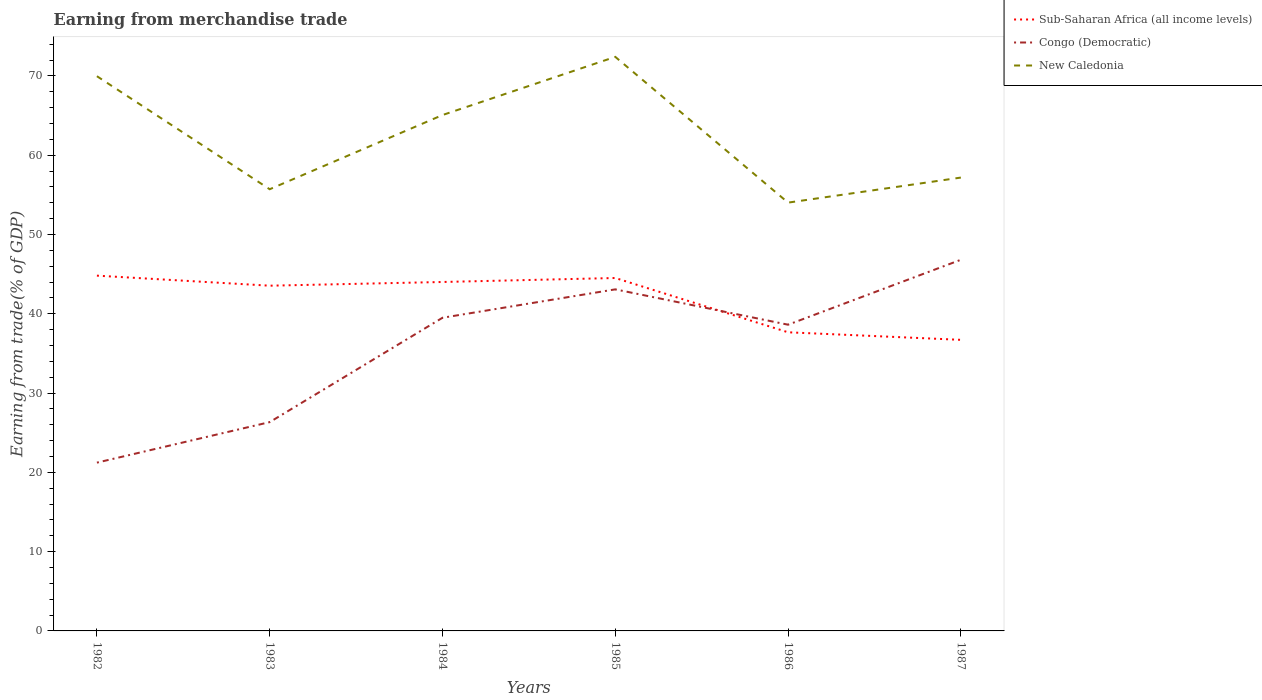Does the line corresponding to Congo (Democratic) intersect with the line corresponding to Sub-Saharan Africa (all income levels)?
Give a very brief answer. Yes. Across all years, what is the maximum earnings from trade in Congo (Democratic)?
Your response must be concise. 21.23. In which year was the earnings from trade in New Caledonia maximum?
Your answer should be very brief. 1986. What is the total earnings from trade in Sub-Saharan Africa (all income levels) in the graph?
Provide a short and direct response. 7.8. What is the difference between the highest and the second highest earnings from trade in Sub-Saharan Africa (all income levels)?
Make the answer very short. 8.1. How many lines are there?
Ensure brevity in your answer.  3. How many years are there in the graph?
Give a very brief answer. 6. Are the values on the major ticks of Y-axis written in scientific E-notation?
Keep it short and to the point. No. Where does the legend appear in the graph?
Provide a short and direct response. Top right. How many legend labels are there?
Offer a terse response. 3. How are the legend labels stacked?
Provide a succinct answer. Vertical. What is the title of the graph?
Offer a terse response. Earning from merchandise trade. Does "Togo" appear as one of the legend labels in the graph?
Provide a succinct answer. No. What is the label or title of the X-axis?
Offer a terse response. Years. What is the label or title of the Y-axis?
Provide a succinct answer. Earning from trade(% of GDP). What is the Earning from trade(% of GDP) of Sub-Saharan Africa (all income levels) in 1982?
Provide a short and direct response. 44.81. What is the Earning from trade(% of GDP) in Congo (Democratic) in 1982?
Your response must be concise. 21.23. What is the Earning from trade(% of GDP) in New Caledonia in 1982?
Provide a short and direct response. 69.97. What is the Earning from trade(% of GDP) in Sub-Saharan Africa (all income levels) in 1983?
Ensure brevity in your answer.  43.55. What is the Earning from trade(% of GDP) in Congo (Democratic) in 1983?
Offer a very short reply. 26.34. What is the Earning from trade(% of GDP) of New Caledonia in 1983?
Provide a short and direct response. 55.72. What is the Earning from trade(% of GDP) of Sub-Saharan Africa (all income levels) in 1984?
Give a very brief answer. 44.02. What is the Earning from trade(% of GDP) in Congo (Democratic) in 1984?
Give a very brief answer. 39.5. What is the Earning from trade(% of GDP) of New Caledonia in 1984?
Your answer should be very brief. 65.07. What is the Earning from trade(% of GDP) of Sub-Saharan Africa (all income levels) in 1985?
Ensure brevity in your answer.  44.52. What is the Earning from trade(% of GDP) in Congo (Democratic) in 1985?
Give a very brief answer. 43.09. What is the Earning from trade(% of GDP) of New Caledonia in 1985?
Give a very brief answer. 72.41. What is the Earning from trade(% of GDP) of Sub-Saharan Africa (all income levels) in 1986?
Provide a succinct answer. 37.67. What is the Earning from trade(% of GDP) in Congo (Democratic) in 1986?
Your answer should be compact. 38.63. What is the Earning from trade(% of GDP) in New Caledonia in 1986?
Provide a short and direct response. 54.03. What is the Earning from trade(% of GDP) in Sub-Saharan Africa (all income levels) in 1987?
Keep it short and to the point. 36.72. What is the Earning from trade(% of GDP) in Congo (Democratic) in 1987?
Your answer should be very brief. 46.82. What is the Earning from trade(% of GDP) of New Caledonia in 1987?
Provide a succinct answer. 57.19. Across all years, what is the maximum Earning from trade(% of GDP) of Sub-Saharan Africa (all income levels)?
Keep it short and to the point. 44.81. Across all years, what is the maximum Earning from trade(% of GDP) in Congo (Democratic)?
Give a very brief answer. 46.82. Across all years, what is the maximum Earning from trade(% of GDP) in New Caledonia?
Make the answer very short. 72.41. Across all years, what is the minimum Earning from trade(% of GDP) of Sub-Saharan Africa (all income levels)?
Keep it short and to the point. 36.72. Across all years, what is the minimum Earning from trade(% of GDP) of Congo (Democratic)?
Make the answer very short. 21.23. Across all years, what is the minimum Earning from trade(% of GDP) of New Caledonia?
Your response must be concise. 54.03. What is the total Earning from trade(% of GDP) of Sub-Saharan Africa (all income levels) in the graph?
Your response must be concise. 251.28. What is the total Earning from trade(% of GDP) in Congo (Democratic) in the graph?
Your answer should be compact. 215.6. What is the total Earning from trade(% of GDP) in New Caledonia in the graph?
Ensure brevity in your answer.  374.39. What is the difference between the Earning from trade(% of GDP) in Sub-Saharan Africa (all income levels) in 1982 and that in 1983?
Your response must be concise. 1.27. What is the difference between the Earning from trade(% of GDP) in Congo (Democratic) in 1982 and that in 1983?
Keep it short and to the point. -5.11. What is the difference between the Earning from trade(% of GDP) of New Caledonia in 1982 and that in 1983?
Keep it short and to the point. 14.26. What is the difference between the Earning from trade(% of GDP) of Sub-Saharan Africa (all income levels) in 1982 and that in 1984?
Provide a short and direct response. 0.8. What is the difference between the Earning from trade(% of GDP) in Congo (Democratic) in 1982 and that in 1984?
Offer a terse response. -18.27. What is the difference between the Earning from trade(% of GDP) of New Caledonia in 1982 and that in 1984?
Provide a short and direct response. 4.9. What is the difference between the Earning from trade(% of GDP) of Sub-Saharan Africa (all income levels) in 1982 and that in 1985?
Offer a terse response. 0.3. What is the difference between the Earning from trade(% of GDP) in Congo (Democratic) in 1982 and that in 1985?
Offer a terse response. -21.86. What is the difference between the Earning from trade(% of GDP) in New Caledonia in 1982 and that in 1985?
Your response must be concise. -2.44. What is the difference between the Earning from trade(% of GDP) in Sub-Saharan Africa (all income levels) in 1982 and that in 1986?
Offer a very short reply. 7.14. What is the difference between the Earning from trade(% of GDP) of Congo (Democratic) in 1982 and that in 1986?
Your response must be concise. -17.4. What is the difference between the Earning from trade(% of GDP) in New Caledonia in 1982 and that in 1986?
Make the answer very short. 15.95. What is the difference between the Earning from trade(% of GDP) in Sub-Saharan Africa (all income levels) in 1982 and that in 1987?
Provide a short and direct response. 8.1. What is the difference between the Earning from trade(% of GDP) of Congo (Democratic) in 1982 and that in 1987?
Your answer should be compact. -25.59. What is the difference between the Earning from trade(% of GDP) in New Caledonia in 1982 and that in 1987?
Provide a succinct answer. 12.79. What is the difference between the Earning from trade(% of GDP) in Sub-Saharan Africa (all income levels) in 1983 and that in 1984?
Make the answer very short. -0.47. What is the difference between the Earning from trade(% of GDP) in Congo (Democratic) in 1983 and that in 1984?
Offer a very short reply. -13.16. What is the difference between the Earning from trade(% of GDP) of New Caledonia in 1983 and that in 1984?
Provide a succinct answer. -9.36. What is the difference between the Earning from trade(% of GDP) of Sub-Saharan Africa (all income levels) in 1983 and that in 1985?
Ensure brevity in your answer.  -0.97. What is the difference between the Earning from trade(% of GDP) in Congo (Democratic) in 1983 and that in 1985?
Keep it short and to the point. -16.75. What is the difference between the Earning from trade(% of GDP) of New Caledonia in 1983 and that in 1985?
Your answer should be compact. -16.7. What is the difference between the Earning from trade(% of GDP) in Sub-Saharan Africa (all income levels) in 1983 and that in 1986?
Provide a short and direct response. 5.88. What is the difference between the Earning from trade(% of GDP) of Congo (Democratic) in 1983 and that in 1986?
Keep it short and to the point. -12.29. What is the difference between the Earning from trade(% of GDP) in New Caledonia in 1983 and that in 1986?
Give a very brief answer. 1.69. What is the difference between the Earning from trade(% of GDP) of Sub-Saharan Africa (all income levels) in 1983 and that in 1987?
Keep it short and to the point. 6.83. What is the difference between the Earning from trade(% of GDP) of Congo (Democratic) in 1983 and that in 1987?
Provide a succinct answer. -20.48. What is the difference between the Earning from trade(% of GDP) of New Caledonia in 1983 and that in 1987?
Your response must be concise. -1.47. What is the difference between the Earning from trade(% of GDP) of Sub-Saharan Africa (all income levels) in 1984 and that in 1985?
Offer a terse response. -0.5. What is the difference between the Earning from trade(% of GDP) in Congo (Democratic) in 1984 and that in 1985?
Provide a short and direct response. -3.58. What is the difference between the Earning from trade(% of GDP) in New Caledonia in 1984 and that in 1985?
Make the answer very short. -7.34. What is the difference between the Earning from trade(% of GDP) of Sub-Saharan Africa (all income levels) in 1984 and that in 1986?
Offer a terse response. 6.35. What is the difference between the Earning from trade(% of GDP) in Congo (Democratic) in 1984 and that in 1986?
Keep it short and to the point. 0.88. What is the difference between the Earning from trade(% of GDP) of New Caledonia in 1984 and that in 1986?
Offer a terse response. 11.05. What is the difference between the Earning from trade(% of GDP) of Sub-Saharan Africa (all income levels) in 1984 and that in 1987?
Ensure brevity in your answer.  7.3. What is the difference between the Earning from trade(% of GDP) in Congo (Democratic) in 1984 and that in 1987?
Make the answer very short. -7.32. What is the difference between the Earning from trade(% of GDP) in New Caledonia in 1984 and that in 1987?
Make the answer very short. 7.89. What is the difference between the Earning from trade(% of GDP) in Sub-Saharan Africa (all income levels) in 1985 and that in 1986?
Your answer should be very brief. 6.85. What is the difference between the Earning from trade(% of GDP) of Congo (Democratic) in 1985 and that in 1986?
Offer a very short reply. 4.46. What is the difference between the Earning from trade(% of GDP) of New Caledonia in 1985 and that in 1986?
Ensure brevity in your answer.  18.39. What is the difference between the Earning from trade(% of GDP) of Sub-Saharan Africa (all income levels) in 1985 and that in 1987?
Give a very brief answer. 7.8. What is the difference between the Earning from trade(% of GDP) in Congo (Democratic) in 1985 and that in 1987?
Give a very brief answer. -3.73. What is the difference between the Earning from trade(% of GDP) of New Caledonia in 1985 and that in 1987?
Keep it short and to the point. 15.23. What is the difference between the Earning from trade(% of GDP) of Sub-Saharan Africa (all income levels) in 1986 and that in 1987?
Your answer should be compact. 0.95. What is the difference between the Earning from trade(% of GDP) in Congo (Democratic) in 1986 and that in 1987?
Provide a succinct answer. -8.19. What is the difference between the Earning from trade(% of GDP) in New Caledonia in 1986 and that in 1987?
Offer a terse response. -3.16. What is the difference between the Earning from trade(% of GDP) in Sub-Saharan Africa (all income levels) in 1982 and the Earning from trade(% of GDP) in Congo (Democratic) in 1983?
Ensure brevity in your answer.  18.48. What is the difference between the Earning from trade(% of GDP) of Sub-Saharan Africa (all income levels) in 1982 and the Earning from trade(% of GDP) of New Caledonia in 1983?
Keep it short and to the point. -10.9. What is the difference between the Earning from trade(% of GDP) in Congo (Democratic) in 1982 and the Earning from trade(% of GDP) in New Caledonia in 1983?
Ensure brevity in your answer.  -34.49. What is the difference between the Earning from trade(% of GDP) of Sub-Saharan Africa (all income levels) in 1982 and the Earning from trade(% of GDP) of Congo (Democratic) in 1984?
Ensure brevity in your answer.  5.31. What is the difference between the Earning from trade(% of GDP) of Sub-Saharan Africa (all income levels) in 1982 and the Earning from trade(% of GDP) of New Caledonia in 1984?
Make the answer very short. -20.26. What is the difference between the Earning from trade(% of GDP) in Congo (Democratic) in 1982 and the Earning from trade(% of GDP) in New Caledonia in 1984?
Make the answer very short. -43.85. What is the difference between the Earning from trade(% of GDP) of Sub-Saharan Africa (all income levels) in 1982 and the Earning from trade(% of GDP) of Congo (Democratic) in 1985?
Your answer should be compact. 1.73. What is the difference between the Earning from trade(% of GDP) of Sub-Saharan Africa (all income levels) in 1982 and the Earning from trade(% of GDP) of New Caledonia in 1985?
Ensure brevity in your answer.  -27.6. What is the difference between the Earning from trade(% of GDP) in Congo (Democratic) in 1982 and the Earning from trade(% of GDP) in New Caledonia in 1985?
Make the answer very short. -51.18. What is the difference between the Earning from trade(% of GDP) of Sub-Saharan Africa (all income levels) in 1982 and the Earning from trade(% of GDP) of Congo (Democratic) in 1986?
Offer a very short reply. 6.19. What is the difference between the Earning from trade(% of GDP) in Sub-Saharan Africa (all income levels) in 1982 and the Earning from trade(% of GDP) in New Caledonia in 1986?
Keep it short and to the point. -9.21. What is the difference between the Earning from trade(% of GDP) in Congo (Democratic) in 1982 and the Earning from trade(% of GDP) in New Caledonia in 1986?
Make the answer very short. -32.8. What is the difference between the Earning from trade(% of GDP) of Sub-Saharan Africa (all income levels) in 1982 and the Earning from trade(% of GDP) of Congo (Democratic) in 1987?
Make the answer very short. -2. What is the difference between the Earning from trade(% of GDP) in Sub-Saharan Africa (all income levels) in 1982 and the Earning from trade(% of GDP) in New Caledonia in 1987?
Give a very brief answer. -12.37. What is the difference between the Earning from trade(% of GDP) of Congo (Democratic) in 1982 and the Earning from trade(% of GDP) of New Caledonia in 1987?
Give a very brief answer. -35.96. What is the difference between the Earning from trade(% of GDP) in Sub-Saharan Africa (all income levels) in 1983 and the Earning from trade(% of GDP) in Congo (Democratic) in 1984?
Make the answer very short. 4.05. What is the difference between the Earning from trade(% of GDP) of Sub-Saharan Africa (all income levels) in 1983 and the Earning from trade(% of GDP) of New Caledonia in 1984?
Keep it short and to the point. -21.53. What is the difference between the Earning from trade(% of GDP) in Congo (Democratic) in 1983 and the Earning from trade(% of GDP) in New Caledonia in 1984?
Keep it short and to the point. -38.74. What is the difference between the Earning from trade(% of GDP) in Sub-Saharan Africa (all income levels) in 1983 and the Earning from trade(% of GDP) in Congo (Democratic) in 1985?
Provide a succinct answer. 0.46. What is the difference between the Earning from trade(% of GDP) of Sub-Saharan Africa (all income levels) in 1983 and the Earning from trade(% of GDP) of New Caledonia in 1985?
Make the answer very short. -28.86. What is the difference between the Earning from trade(% of GDP) in Congo (Democratic) in 1983 and the Earning from trade(% of GDP) in New Caledonia in 1985?
Give a very brief answer. -46.07. What is the difference between the Earning from trade(% of GDP) of Sub-Saharan Africa (all income levels) in 1983 and the Earning from trade(% of GDP) of Congo (Democratic) in 1986?
Provide a succinct answer. 4.92. What is the difference between the Earning from trade(% of GDP) in Sub-Saharan Africa (all income levels) in 1983 and the Earning from trade(% of GDP) in New Caledonia in 1986?
Make the answer very short. -10.48. What is the difference between the Earning from trade(% of GDP) of Congo (Democratic) in 1983 and the Earning from trade(% of GDP) of New Caledonia in 1986?
Keep it short and to the point. -27.69. What is the difference between the Earning from trade(% of GDP) in Sub-Saharan Africa (all income levels) in 1983 and the Earning from trade(% of GDP) in Congo (Democratic) in 1987?
Your answer should be compact. -3.27. What is the difference between the Earning from trade(% of GDP) in Sub-Saharan Africa (all income levels) in 1983 and the Earning from trade(% of GDP) in New Caledonia in 1987?
Make the answer very short. -13.64. What is the difference between the Earning from trade(% of GDP) in Congo (Democratic) in 1983 and the Earning from trade(% of GDP) in New Caledonia in 1987?
Your response must be concise. -30.85. What is the difference between the Earning from trade(% of GDP) of Sub-Saharan Africa (all income levels) in 1984 and the Earning from trade(% of GDP) of Congo (Democratic) in 1985?
Ensure brevity in your answer.  0.93. What is the difference between the Earning from trade(% of GDP) in Sub-Saharan Africa (all income levels) in 1984 and the Earning from trade(% of GDP) in New Caledonia in 1985?
Offer a very short reply. -28.4. What is the difference between the Earning from trade(% of GDP) in Congo (Democratic) in 1984 and the Earning from trade(% of GDP) in New Caledonia in 1985?
Ensure brevity in your answer.  -32.91. What is the difference between the Earning from trade(% of GDP) of Sub-Saharan Africa (all income levels) in 1984 and the Earning from trade(% of GDP) of Congo (Democratic) in 1986?
Give a very brief answer. 5.39. What is the difference between the Earning from trade(% of GDP) of Sub-Saharan Africa (all income levels) in 1984 and the Earning from trade(% of GDP) of New Caledonia in 1986?
Your answer should be compact. -10.01. What is the difference between the Earning from trade(% of GDP) in Congo (Democratic) in 1984 and the Earning from trade(% of GDP) in New Caledonia in 1986?
Provide a succinct answer. -14.52. What is the difference between the Earning from trade(% of GDP) of Sub-Saharan Africa (all income levels) in 1984 and the Earning from trade(% of GDP) of Congo (Democratic) in 1987?
Your answer should be compact. -2.8. What is the difference between the Earning from trade(% of GDP) of Sub-Saharan Africa (all income levels) in 1984 and the Earning from trade(% of GDP) of New Caledonia in 1987?
Give a very brief answer. -13.17. What is the difference between the Earning from trade(% of GDP) in Congo (Democratic) in 1984 and the Earning from trade(% of GDP) in New Caledonia in 1987?
Give a very brief answer. -17.68. What is the difference between the Earning from trade(% of GDP) of Sub-Saharan Africa (all income levels) in 1985 and the Earning from trade(% of GDP) of Congo (Democratic) in 1986?
Your answer should be compact. 5.89. What is the difference between the Earning from trade(% of GDP) of Sub-Saharan Africa (all income levels) in 1985 and the Earning from trade(% of GDP) of New Caledonia in 1986?
Provide a short and direct response. -9.51. What is the difference between the Earning from trade(% of GDP) of Congo (Democratic) in 1985 and the Earning from trade(% of GDP) of New Caledonia in 1986?
Offer a very short reply. -10.94. What is the difference between the Earning from trade(% of GDP) of Sub-Saharan Africa (all income levels) in 1985 and the Earning from trade(% of GDP) of Congo (Democratic) in 1987?
Provide a succinct answer. -2.3. What is the difference between the Earning from trade(% of GDP) in Sub-Saharan Africa (all income levels) in 1985 and the Earning from trade(% of GDP) in New Caledonia in 1987?
Offer a terse response. -12.67. What is the difference between the Earning from trade(% of GDP) in Congo (Democratic) in 1985 and the Earning from trade(% of GDP) in New Caledonia in 1987?
Your response must be concise. -14.1. What is the difference between the Earning from trade(% of GDP) in Sub-Saharan Africa (all income levels) in 1986 and the Earning from trade(% of GDP) in Congo (Democratic) in 1987?
Your response must be concise. -9.15. What is the difference between the Earning from trade(% of GDP) of Sub-Saharan Africa (all income levels) in 1986 and the Earning from trade(% of GDP) of New Caledonia in 1987?
Your answer should be very brief. -19.52. What is the difference between the Earning from trade(% of GDP) of Congo (Democratic) in 1986 and the Earning from trade(% of GDP) of New Caledonia in 1987?
Your answer should be compact. -18.56. What is the average Earning from trade(% of GDP) in Sub-Saharan Africa (all income levels) per year?
Offer a terse response. 41.88. What is the average Earning from trade(% of GDP) of Congo (Democratic) per year?
Offer a terse response. 35.93. What is the average Earning from trade(% of GDP) of New Caledonia per year?
Keep it short and to the point. 62.4. In the year 1982, what is the difference between the Earning from trade(% of GDP) of Sub-Saharan Africa (all income levels) and Earning from trade(% of GDP) of Congo (Democratic)?
Offer a very short reply. 23.59. In the year 1982, what is the difference between the Earning from trade(% of GDP) in Sub-Saharan Africa (all income levels) and Earning from trade(% of GDP) in New Caledonia?
Keep it short and to the point. -25.16. In the year 1982, what is the difference between the Earning from trade(% of GDP) of Congo (Democratic) and Earning from trade(% of GDP) of New Caledonia?
Offer a very short reply. -48.75. In the year 1983, what is the difference between the Earning from trade(% of GDP) in Sub-Saharan Africa (all income levels) and Earning from trade(% of GDP) in Congo (Democratic)?
Keep it short and to the point. 17.21. In the year 1983, what is the difference between the Earning from trade(% of GDP) of Sub-Saharan Africa (all income levels) and Earning from trade(% of GDP) of New Caledonia?
Offer a very short reply. -12.17. In the year 1983, what is the difference between the Earning from trade(% of GDP) of Congo (Democratic) and Earning from trade(% of GDP) of New Caledonia?
Offer a terse response. -29.38. In the year 1984, what is the difference between the Earning from trade(% of GDP) in Sub-Saharan Africa (all income levels) and Earning from trade(% of GDP) in Congo (Democratic)?
Your answer should be compact. 4.51. In the year 1984, what is the difference between the Earning from trade(% of GDP) in Sub-Saharan Africa (all income levels) and Earning from trade(% of GDP) in New Caledonia?
Your answer should be very brief. -21.06. In the year 1984, what is the difference between the Earning from trade(% of GDP) of Congo (Democratic) and Earning from trade(% of GDP) of New Caledonia?
Offer a terse response. -25.57. In the year 1985, what is the difference between the Earning from trade(% of GDP) of Sub-Saharan Africa (all income levels) and Earning from trade(% of GDP) of Congo (Democratic)?
Make the answer very short. 1.43. In the year 1985, what is the difference between the Earning from trade(% of GDP) in Sub-Saharan Africa (all income levels) and Earning from trade(% of GDP) in New Caledonia?
Provide a succinct answer. -27.89. In the year 1985, what is the difference between the Earning from trade(% of GDP) in Congo (Democratic) and Earning from trade(% of GDP) in New Caledonia?
Your response must be concise. -29.33. In the year 1986, what is the difference between the Earning from trade(% of GDP) of Sub-Saharan Africa (all income levels) and Earning from trade(% of GDP) of Congo (Democratic)?
Offer a very short reply. -0.96. In the year 1986, what is the difference between the Earning from trade(% of GDP) of Sub-Saharan Africa (all income levels) and Earning from trade(% of GDP) of New Caledonia?
Provide a succinct answer. -16.36. In the year 1986, what is the difference between the Earning from trade(% of GDP) in Congo (Democratic) and Earning from trade(% of GDP) in New Caledonia?
Offer a terse response. -15.4. In the year 1987, what is the difference between the Earning from trade(% of GDP) of Sub-Saharan Africa (all income levels) and Earning from trade(% of GDP) of Congo (Democratic)?
Give a very brief answer. -10.1. In the year 1987, what is the difference between the Earning from trade(% of GDP) in Sub-Saharan Africa (all income levels) and Earning from trade(% of GDP) in New Caledonia?
Provide a succinct answer. -20.47. In the year 1987, what is the difference between the Earning from trade(% of GDP) of Congo (Democratic) and Earning from trade(% of GDP) of New Caledonia?
Keep it short and to the point. -10.37. What is the ratio of the Earning from trade(% of GDP) in Sub-Saharan Africa (all income levels) in 1982 to that in 1983?
Provide a succinct answer. 1.03. What is the ratio of the Earning from trade(% of GDP) of Congo (Democratic) in 1982 to that in 1983?
Make the answer very short. 0.81. What is the ratio of the Earning from trade(% of GDP) of New Caledonia in 1982 to that in 1983?
Make the answer very short. 1.26. What is the ratio of the Earning from trade(% of GDP) in Sub-Saharan Africa (all income levels) in 1982 to that in 1984?
Provide a short and direct response. 1.02. What is the ratio of the Earning from trade(% of GDP) in Congo (Democratic) in 1982 to that in 1984?
Ensure brevity in your answer.  0.54. What is the ratio of the Earning from trade(% of GDP) in New Caledonia in 1982 to that in 1984?
Give a very brief answer. 1.08. What is the ratio of the Earning from trade(% of GDP) of Sub-Saharan Africa (all income levels) in 1982 to that in 1985?
Your response must be concise. 1.01. What is the ratio of the Earning from trade(% of GDP) in Congo (Democratic) in 1982 to that in 1985?
Provide a succinct answer. 0.49. What is the ratio of the Earning from trade(% of GDP) of New Caledonia in 1982 to that in 1985?
Give a very brief answer. 0.97. What is the ratio of the Earning from trade(% of GDP) in Sub-Saharan Africa (all income levels) in 1982 to that in 1986?
Your answer should be compact. 1.19. What is the ratio of the Earning from trade(% of GDP) of Congo (Democratic) in 1982 to that in 1986?
Your response must be concise. 0.55. What is the ratio of the Earning from trade(% of GDP) in New Caledonia in 1982 to that in 1986?
Make the answer very short. 1.3. What is the ratio of the Earning from trade(% of GDP) of Sub-Saharan Africa (all income levels) in 1982 to that in 1987?
Offer a very short reply. 1.22. What is the ratio of the Earning from trade(% of GDP) in Congo (Democratic) in 1982 to that in 1987?
Provide a succinct answer. 0.45. What is the ratio of the Earning from trade(% of GDP) of New Caledonia in 1982 to that in 1987?
Keep it short and to the point. 1.22. What is the ratio of the Earning from trade(% of GDP) in Sub-Saharan Africa (all income levels) in 1983 to that in 1984?
Keep it short and to the point. 0.99. What is the ratio of the Earning from trade(% of GDP) in Congo (Democratic) in 1983 to that in 1984?
Give a very brief answer. 0.67. What is the ratio of the Earning from trade(% of GDP) in New Caledonia in 1983 to that in 1984?
Offer a very short reply. 0.86. What is the ratio of the Earning from trade(% of GDP) of Sub-Saharan Africa (all income levels) in 1983 to that in 1985?
Offer a very short reply. 0.98. What is the ratio of the Earning from trade(% of GDP) of Congo (Democratic) in 1983 to that in 1985?
Offer a very short reply. 0.61. What is the ratio of the Earning from trade(% of GDP) of New Caledonia in 1983 to that in 1985?
Provide a succinct answer. 0.77. What is the ratio of the Earning from trade(% of GDP) in Sub-Saharan Africa (all income levels) in 1983 to that in 1986?
Your answer should be compact. 1.16. What is the ratio of the Earning from trade(% of GDP) in Congo (Democratic) in 1983 to that in 1986?
Provide a succinct answer. 0.68. What is the ratio of the Earning from trade(% of GDP) in New Caledonia in 1983 to that in 1986?
Your answer should be very brief. 1.03. What is the ratio of the Earning from trade(% of GDP) in Sub-Saharan Africa (all income levels) in 1983 to that in 1987?
Give a very brief answer. 1.19. What is the ratio of the Earning from trade(% of GDP) in Congo (Democratic) in 1983 to that in 1987?
Your answer should be very brief. 0.56. What is the ratio of the Earning from trade(% of GDP) of New Caledonia in 1983 to that in 1987?
Your answer should be compact. 0.97. What is the ratio of the Earning from trade(% of GDP) of Sub-Saharan Africa (all income levels) in 1984 to that in 1985?
Your response must be concise. 0.99. What is the ratio of the Earning from trade(% of GDP) in Congo (Democratic) in 1984 to that in 1985?
Your response must be concise. 0.92. What is the ratio of the Earning from trade(% of GDP) in New Caledonia in 1984 to that in 1985?
Your answer should be compact. 0.9. What is the ratio of the Earning from trade(% of GDP) of Sub-Saharan Africa (all income levels) in 1984 to that in 1986?
Provide a short and direct response. 1.17. What is the ratio of the Earning from trade(% of GDP) in Congo (Democratic) in 1984 to that in 1986?
Give a very brief answer. 1.02. What is the ratio of the Earning from trade(% of GDP) in New Caledonia in 1984 to that in 1986?
Your answer should be compact. 1.2. What is the ratio of the Earning from trade(% of GDP) in Sub-Saharan Africa (all income levels) in 1984 to that in 1987?
Your answer should be very brief. 1.2. What is the ratio of the Earning from trade(% of GDP) of Congo (Democratic) in 1984 to that in 1987?
Give a very brief answer. 0.84. What is the ratio of the Earning from trade(% of GDP) of New Caledonia in 1984 to that in 1987?
Give a very brief answer. 1.14. What is the ratio of the Earning from trade(% of GDP) of Sub-Saharan Africa (all income levels) in 1985 to that in 1986?
Keep it short and to the point. 1.18. What is the ratio of the Earning from trade(% of GDP) in Congo (Democratic) in 1985 to that in 1986?
Make the answer very short. 1.12. What is the ratio of the Earning from trade(% of GDP) in New Caledonia in 1985 to that in 1986?
Offer a terse response. 1.34. What is the ratio of the Earning from trade(% of GDP) of Sub-Saharan Africa (all income levels) in 1985 to that in 1987?
Ensure brevity in your answer.  1.21. What is the ratio of the Earning from trade(% of GDP) of Congo (Democratic) in 1985 to that in 1987?
Offer a terse response. 0.92. What is the ratio of the Earning from trade(% of GDP) of New Caledonia in 1985 to that in 1987?
Your answer should be compact. 1.27. What is the ratio of the Earning from trade(% of GDP) of Sub-Saharan Africa (all income levels) in 1986 to that in 1987?
Your response must be concise. 1.03. What is the ratio of the Earning from trade(% of GDP) of Congo (Democratic) in 1986 to that in 1987?
Give a very brief answer. 0.83. What is the ratio of the Earning from trade(% of GDP) in New Caledonia in 1986 to that in 1987?
Offer a very short reply. 0.94. What is the difference between the highest and the second highest Earning from trade(% of GDP) in Sub-Saharan Africa (all income levels)?
Your response must be concise. 0.3. What is the difference between the highest and the second highest Earning from trade(% of GDP) of Congo (Democratic)?
Ensure brevity in your answer.  3.73. What is the difference between the highest and the second highest Earning from trade(% of GDP) of New Caledonia?
Keep it short and to the point. 2.44. What is the difference between the highest and the lowest Earning from trade(% of GDP) in Sub-Saharan Africa (all income levels)?
Your response must be concise. 8.1. What is the difference between the highest and the lowest Earning from trade(% of GDP) in Congo (Democratic)?
Offer a very short reply. 25.59. What is the difference between the highest and the lowest Earning from trade(% of GDP) of New Caledonia?
Provide a succinct answer. 18.39. 